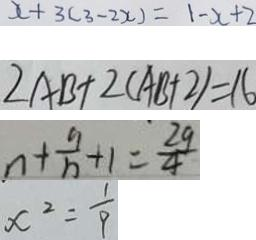Convert formula to latex. <formula><loc_0><loc_0><loc_500><loc_500>x + 3 ( 3 - 2 x ) = 1 - x + 2 
 2 A B + 2 ( A B + 2 ) = 1 6 
 n + \frac { 9 } { n } + 1 = \frac { 2 9 } { 4 } 
 x ^ { 2 } = \frac { 1 } { 9 }</formula> 